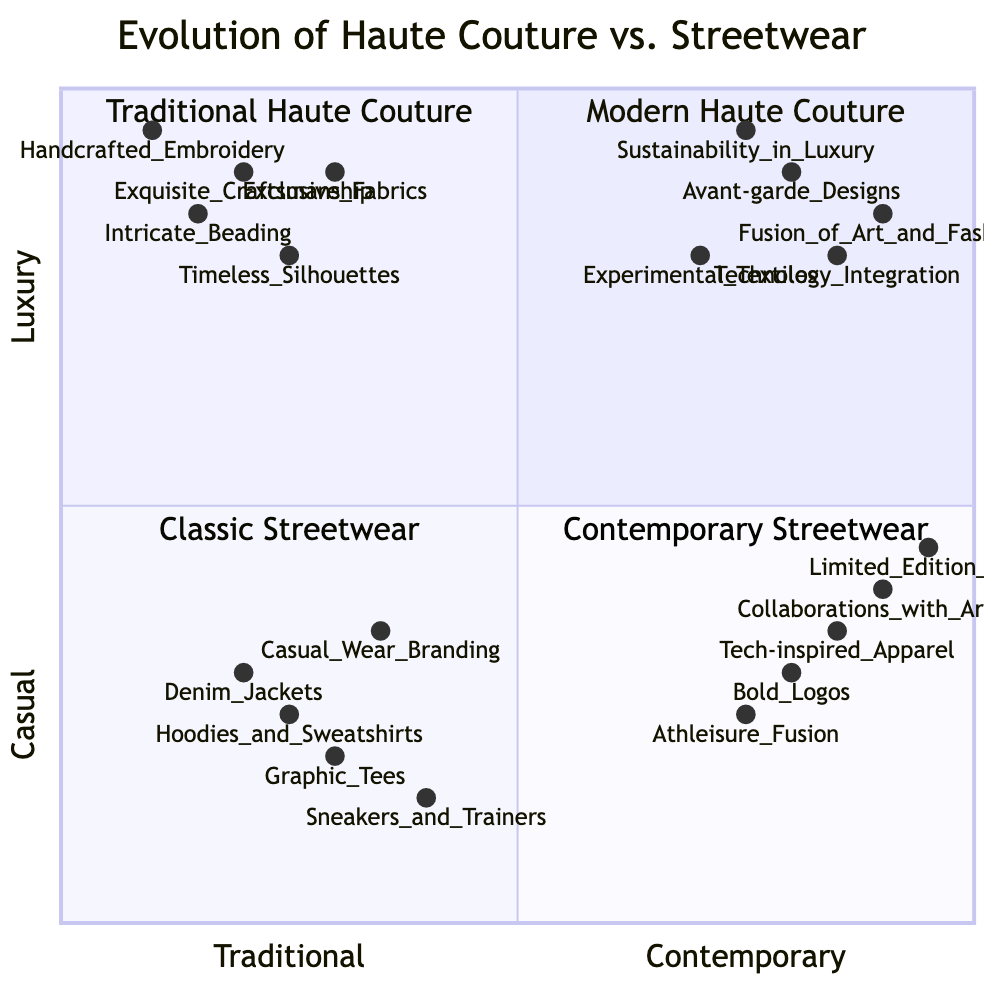What are the key elements of Traditional Haute Couture? Traditional Haute Couture includes elements such as Exquisite Craftsmanship, Handcrafted Embroidery, Intricate Beading, Exclusive Fabrics, and Timeless Silhouettes. These elements are represented in the Top Left quadrant of the diagram.
Answer: Exquisite Craftsmanship, Handcrafted Embroidery, Intricate Beading, Exclusive Fabrics, Timeless Silhouettes What is the dominant theme in Contemporary Streetwear? The dominant theme in Contemporary Streetwear revolves around Bold Logos, Collaborations with Artists, Tech-inspired Apparel, Athleisure Fusion, and Limited Edition Drops, as illustrated in the Bottom Right quadrant.
Answer: Bold Logos, Collaborations with Artists, Tech-inspired Apparel, Athleisure Fusion, Limited Edition Drops Which quadrant contains Experimental Textiles? Experimental Textiles is located in the Modern Haute Couture quadrant, represented at the coordinates (0.7, 0.8), which places it distinctly in the Top Right area of the diagram.
Answer: Modern Haute Couture What element from Classic Streetwear has the lowest luxury value? Among the elements listed in Classic Streetwear, Sneakers and Trainers has the lowest luxury value at 0.15, indicating a stronger casual association than luxury.
Answer: Sneakers and Trainers How does the relationship between Modern Haute Couture and Contemporary Streetwear compare? To understand their relationship, we look at their respective positions: Modern Haute Couture is in the Top Right, indicating a focus on luxury with a contemporary approach, while Contemporary Streetwear is in the Bottom Right, suggesting a contemporary casual approach. They share a contemporary alignment but diverge in their luxury values.
Answer: Contemporary alignment with different luxury values What is the highest luxury value element in Traditional Haute Couture? Among the elements listed in Traditional Haute Couture, Handcrafted Embroidery has the highest luxury value at 0.95, indicating its strong presence in luxury fashion.
Answer: Handcrafted Embroidery Which streetwear trend shows a significant integration with technology? Tech-inspired Apparel is noted in the Contemporary Streetwear quadrant as an element that demonstrates significant integration with technology, highlighting the fusion of tech advancements within streetwear.
Answer: Tech-inspired Apparel What is the value of avant-garde designs? Avant-garde Designs is positioned at the coordinates (0.8, 0.9) in the Modern Haute Couture quadrant, indicating its high values both in traditional concepts and luxury association.
Answer: (0.8, 0.9) In which quadrant can you find casual wear branding? Casual Wear Branding is found in the Classic Streetwear quadrant at the coordinates (0.35, 0.35), signifying its casual orientation.
Answer: Classic Streetwear 